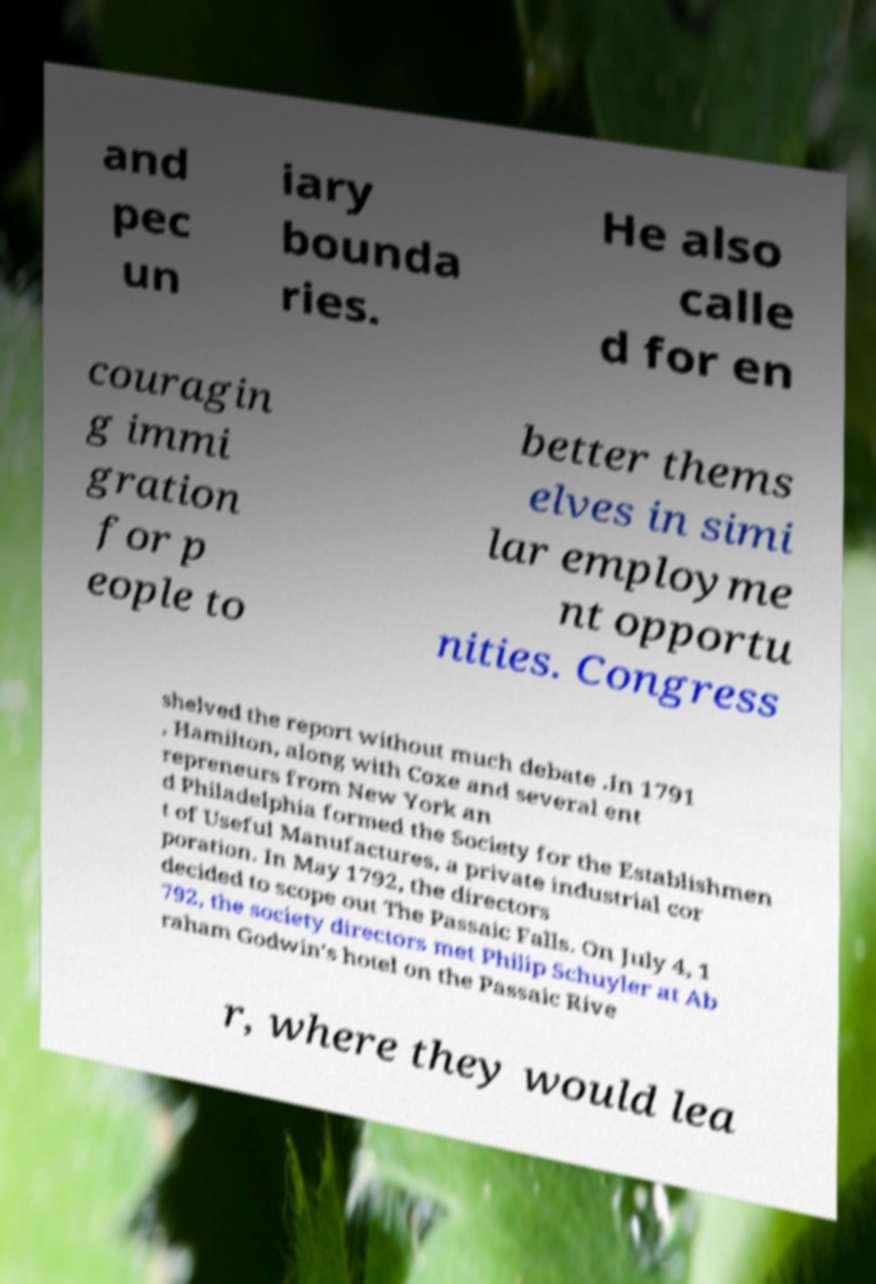There's text embedded in this image that I need extracted. Can you transcribe it verbatim? and pec un iary bounda ries. He also calle d for en couragin g immi gration for p eople to better thems elves in simi lar employme nt opportu nities. Congress shelved the report without much debate .In 1791 , Hamilton, along with Coxe and several ent repreneurs from New York an d Philadelphia formed the Society for the Establishmen t of Useful Manufactures, a private industrial cor poration. In May 1792, the directors decided to scope out The Passaic Falls. On July 4, 1 792, the society directors met Philip Schuyler at Ab raham Godwin's hotel on the Passaic Rive r, where they would lea 